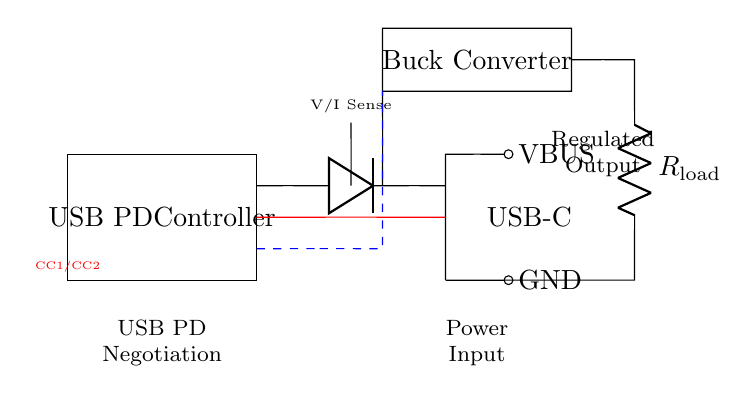What is the power input connector type? The circuit diagram shows that the power input connector is a USB-C connector, indicated by the labeled "USB-C" at the top.
Answer: USB-C What component regulates the output voltage? The buck converter is clearly marked in the diagram and is responsible for stepping down the voltage to the required levels for the load.
Answer: Buck Converter What is the purpose of the USB PD Controller? The USB PD Controller is indicated at the top of the circuit diagram, and its primary function is to handle the power delivery negotiation between the power source and the device.
Answer: Negotiation Which components are part of the sensing mechanism? The "V/I Sense" area in the diagram shows that this part is responsible for voltage and current sensing, which is critical for monitoring and adjusting output parameters.
Answer: V/I Sense What do the CC lines signify in this circuit? The CC lines are labeled as CC1/CC2 in red, and they are used for configuration and communication in USB Power Delivery to manage the connection and power flow.
Answer: CC lines What is the value of the load resistance in this circuit? The circuit diagram shows a resistor labeled as R_load. However, no specific value is provided; it is represented symbolically as R_load.
Answer: R_load How does the power flow from the USB-C connector to the load? The power flows from the USB-C connector through the USB PD Controller, then goes through the diode and buck converter, ultimately reaching the load connected to R_load.
Answer: Through power path and buck converter 